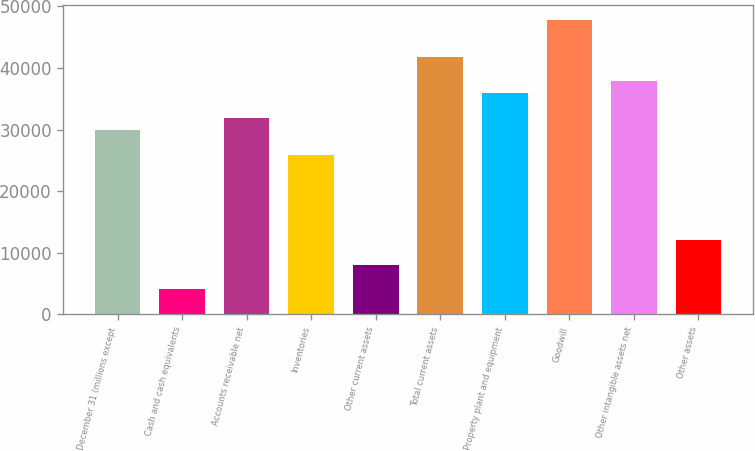<chart> <loc_0><loc_0><loc_500><loc_500><bar_chart><fcel>December 31 (millions except<fcel>Cash and cash equivalents<fcel>Accounts receivable net<fcel>Inventories<fcel>Other current assets<fcel>Total current assets<fcel>Property plant and equipment<fcel>Goodwill<fcel>Other intangible assets net<fcel>Other assets<nl><fcel>29908.5<fcel>4048.64<fcel>31897.7<fcel>25930.1<fcel>8027.08<fcel>41843.8<fcel>35876.2<fcel>47811.5<fcel>37865.4<fcel>12005.5<nl></chart> 